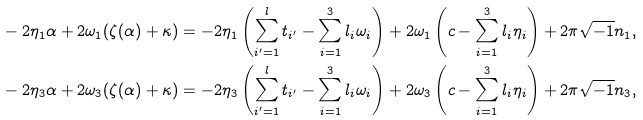<formula> <loc_0><loc_0><loc_500><loc_500>& - 2 \eta _ { 1 } \alpha + 2 \omega _ { 1 } ( \zeta ( \alpha ) + \kappa ) = - 2 \eta _ { 1 } \left ( \sum _ { i ^ { \prime } = 1 } ^ { l } t _ { i ^ { \prime } } - \sum _ { i = 1 } ^ { 3 } l _ { i } \omega _ { i } \right ) + 2 \omega _ { 1 } \left ( c - \sum _ { i = 1 } ^ { 3 } l _ { i } \eta _ { i } \right ) + 2 \pi \sqrt { - 1 } n _ { 1 } , \\ & - 2 \eta _ { 3 } \alpha + 2 \omega _ { 3 } ( \zeta ( \alpha ) + \kappa ) = - 2 \eta _ { 3 } \left ( \sum _ { i ^ { \prime } = 1 } ^ { l } t _ { i ^ { \prime } } - \sum _ { i = 1 } ^ { 3 } l _ { i } \omega _ { i } \right ) + 2 \omega _ { 3 } \left ( c - \sum _ { i = 1 } ^ { 3 } l _ { i } \eta _ { i } \right ) + 2 \pi \sqrt { - 1 } n _ { 3 } ,</formula> 